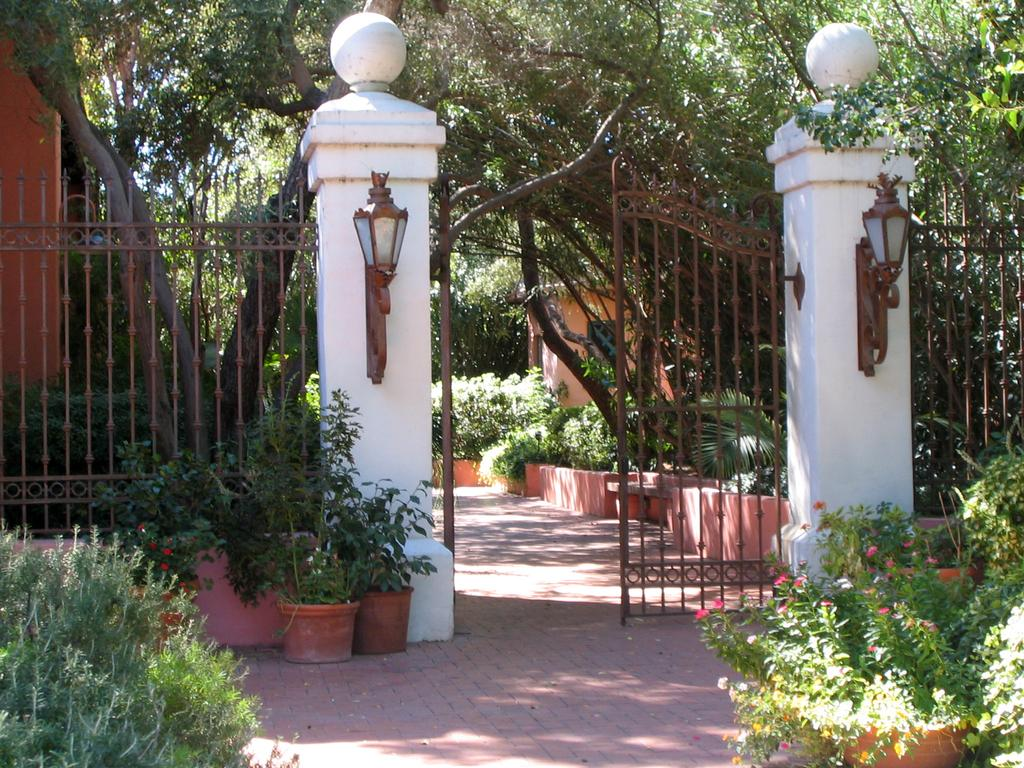What type of structure can be seen in the image? There is a gate in the image. What is associated with the gate in the image? There is fencing in the image. What can be seen illuminating the area in the image? There are lights in the image. What type of vegetation is present in the image? There are trees and plants in the image. What surface is visible in the image? There is a floor visible in the image. What is visible in the background of the image? The sky is visible in the image. Can you tell me how many matches are being held by the trees in the image? There are no matches present in the image; it features a gate, fencing, lights, trees, plants, a floor, and the sky. What type of activity is the pocket engaging in within the image? There is no pocket present in the image, so it cannot be involved in any activity. 